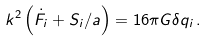Convert formula to latex. <formula><loc_0><loc_0><loc_500><loc_500>k ^ { 2 } \left ( \dot { F } _ { i } + S _ { i } / a \right ) = 1 6 \pi G \delta q _ { i } \, .</formula> 